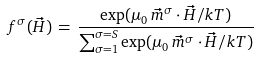<formula> <loc_0><loc_0><loc_500><loc_500>f ^ { \sigma } ( \vec { H } ) \, = \, \frac { \exp ( \mu _ { 0 } \, \vec { m } ^ { \sigma } \cdot \vec { H } / k T ) } { \sum _ { \sigma = 1 } ^ { \sigma = S } \exp ( \mu _ { 0 } \, \vec { m } ^ { \sigma } \cdot \vec { H } / k T ) }</formula> 